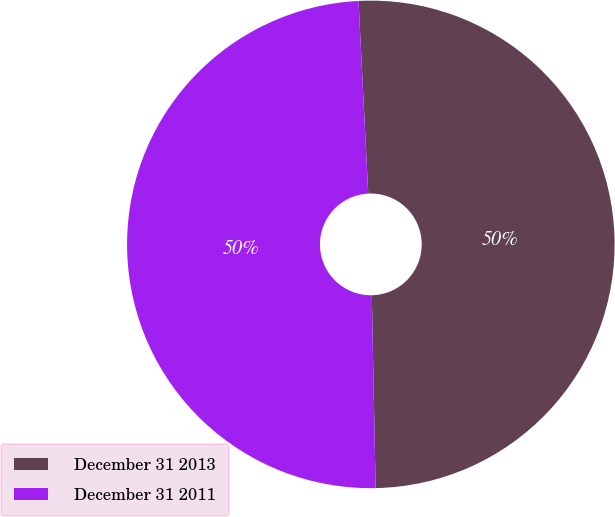Convert chart to OTSL. <chart><loc_0><loc_0><loc_500><loc_500><pie_chart><fcel>December 31 2013<fcel>December 31 2011<nl><fcel>50.49%<fcel>49.51%<nl></chart> 